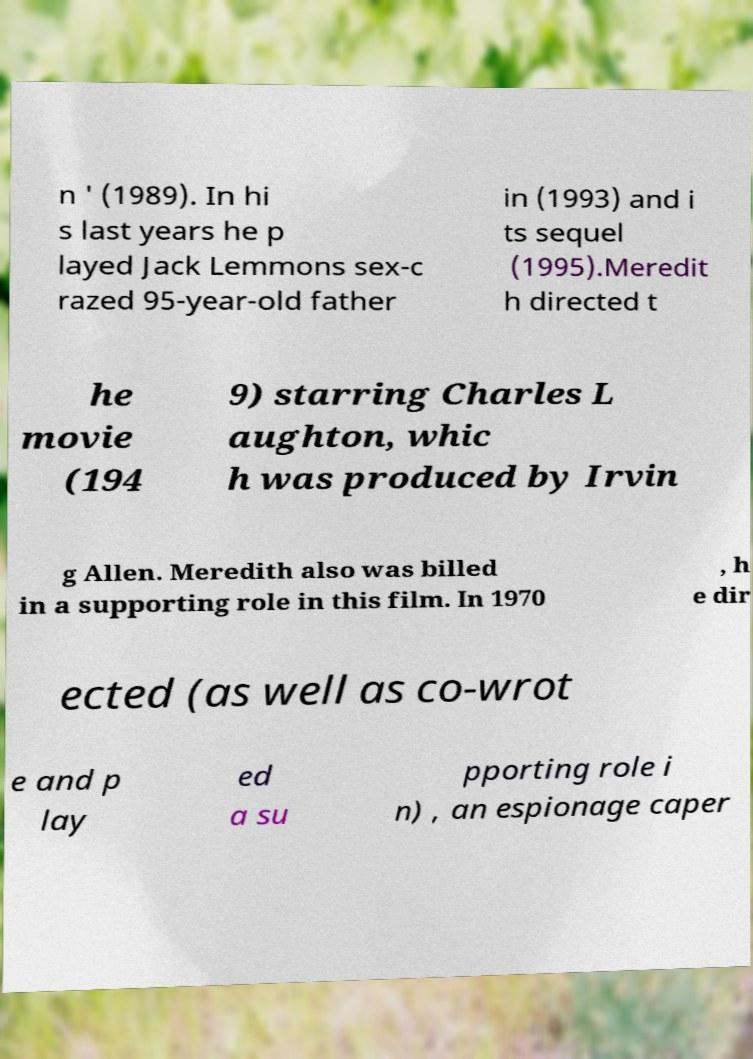I need the written content from this picture converted into text. Can you do that? n ' (1989). In hi s last years he p layed Jack Lemmons sex-c razed 95-year-old father in (1993) and i ts sequel (1995).Meredit h directed t he movie (194 9) starring Charles L aughton, whic h was produced by Irvin g Allen. Meredith also was billed in a supporting role in this film. In 1970 , h e dir ected (as well as co-wrot e and p lay ed a su pporting role i n) , an espionage caper 